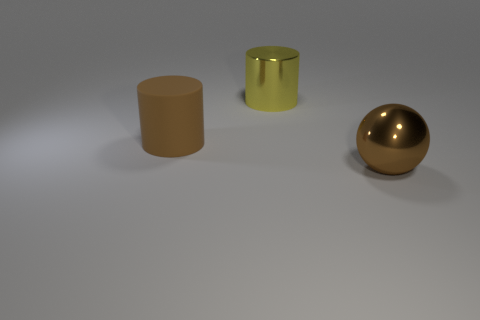Add 3 tiny blue cylinders. How many objects exist? 6 Subtract all yellow cylinders. How many cylinders are left? 1 Subtract all cylinders. How many objects are left? 1 Add 1 large matte things. How many large matte things are left? 2 Add 2 brown things. How many brown things exist? 4 Subtract 0 green cylinders. How many objects are left? 3 Subtract all red cylinders. Subtract all green blocks. How many cylinders are left? 2 Subtract all big matte things. Subtract all balls. How many objects are left? 1 